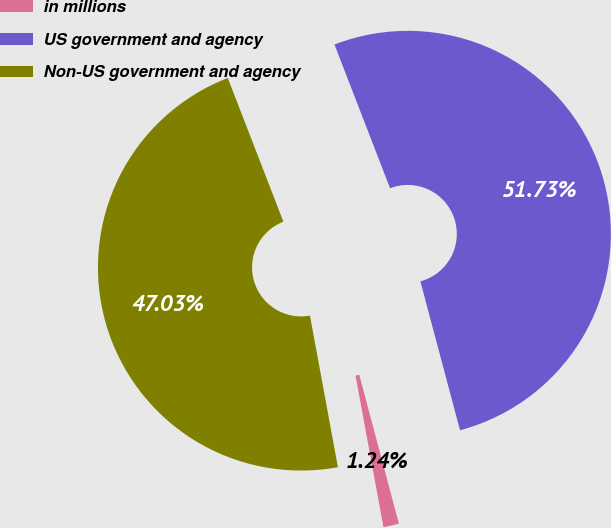Convert chart to OTSL. <chart><loc_0><loc_0><loc_500><loc_500><pie_chart><fcel>in millions<fcel>US government and agency<fcel>Non-US government and agency<nl><fcel>1.24%<fcel>51.74%<fcel>47.03%<nl></chart> 